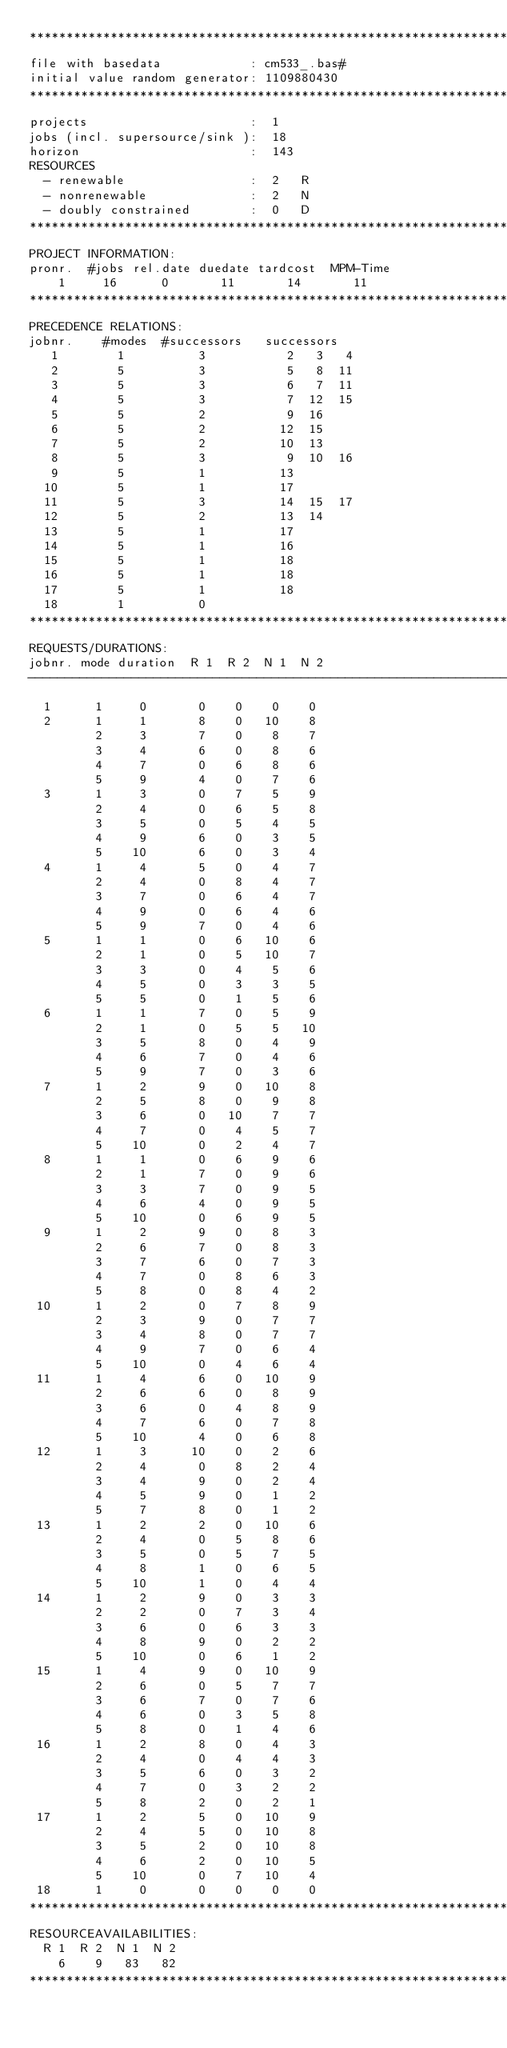<code> <loc_0><loc_0><loc_500><loc_500><_ObjectiveC_>************************************************************************
file with basedata            : cm533_.bas#
initial value random generator: 1109880430
************************************************************************
projects                      :  1
jobs (incl. supersource/sink ):  18
horizon                       :  143
RESOURCES
  - renewable                 :  2   R
  - nonrenewable              :  2   N
  - doubly constrained        :  0   D
************************************************************************
PROJECT INFORMATION:
pronr.  #jobs rel.date duedate tardcost  MPM-Time
    1     16      0       11       14       11
************************************************************************
PRECEDENCE RELATIONS:
jobnr.    #modes  #successors   successors
   1        1          3           2   3   4
   2        5          3           5   8  11
   3        5          3           6   7  11
   4        5          3           7  12  15
   5        5          2           9  16
   6        5          2          12  15
   7        5          2          10  13
   8        5          3           9  10  16
   9        5          1          13
  10        5          1          17
  11        5          3          14  15  17
  12        5          2          13  14
  13        5          1          17
  14        5          1          16
  15        5          1          18
  16        5          1          18
  17        5          1          18
  18        1          0        
************************************************************************
REQUESTS/DURATIONS:
jobnr. mode duration  R 1  R 2  N 1  N 2
------------------------------------------------------------------------
  1      1     0       0    0    0    0
  2      1     1       8    0   10    8
         2     3       7    0    8    7
         3     4       6    0    8    6
         4     7       0    6    8    6
         5     9       4    0    7    6
  3      1     3       0    7    5    9
         2     4       0    6    5    8
         3     5       0    5    4    5
         4     9       6    0    3    5
         5    10       6    0    3    4
  4      1     4       5    0    4    7
         2     4       0    8    4    7
         3     7       0    6    4    7
         4     9       0    6    4    6
         5     9       7    0    4    6
  5      1     1       0    6   10    6
         2     1       0    5   10    7
         3     3       0    4    5    6
         4     5       0    3    3    5
         5     5       0    1    5    6
  6      1     1       7    0    5    9
         2     1       0    5    5   10
         3     5       8    0    4    9
         4     6       7    0    4    6
         5     9       7    0    3    6
  7      1     2       9    0   10    8
         2     5       8    0    9    8
         3     6       0   10    7    7
         4     7       0    4    5    7
         5    10       0    2    4    7
  8      1     1       0    6    9    6
         2     1       7    0    9    6
         3     3       7    0    9    5
         4     6       4    0    9    5
         5    10       0    6    9    5
  9      1     2       9    0    8    3
         2     6       7    0    8    3
         3     7       6    0    7    3
         4     7       0    8    6    3
         5     8       0    8    4    2
 10      1     2       0    7    8    9
         2     3       9    0    7    7
         3     4       8    0    7    7
         4     9       7    0    6    4
         5    10       0    4    6    4
 11      1     4       6    0   10    9
         2     6       6    0    8    9
         3     6       0    4    8    9
         4     7       6    0    7    8
         5    10       4    0    6    8
 12      1     3      10    0    2    6
         2     4       0    8    2    4
         3     4       9    0    2    4
         4     5       9    0    1    2
         5     7       8    0    1    2
 13      1     2       2    0   10    6
         2     4       0    5    8    6
         3     5       0    5    7    5
         4     8       1    0    6    5
         5    10       1    0    4    4
 14      1     2       9    0    3    3
         2     2       0    7    3    4
         3     6       0    6    3    3
         4     8       9    0    2    2
         5    10       0    6    1    2
 15      1     4       9    0   10    9
         2     6       0    5    7    7
         3     6       7    0    7    6
         4     6       0    3    5    8
         5     8       0    1    4    6
 16      1     2       8    0    4    3
         2     4       0    4    4    3
         3     5       6    0    3    2
         4     7       0    3    2    2
         5     8       2    0    2    1
 17      1     2       5    0   10    9
         2     4       5    0   10    8
         3     5       2    0   10    8
         4     6       2    0   10    5
         5    10       0    7   10    4
 18      1     0       0    0    0    0
************************************************************************
RESOURCEAVAILABILITIES:
  R 1  R 2  N 1  N 2
    6    9   83   82
************************************************************************
</code> 